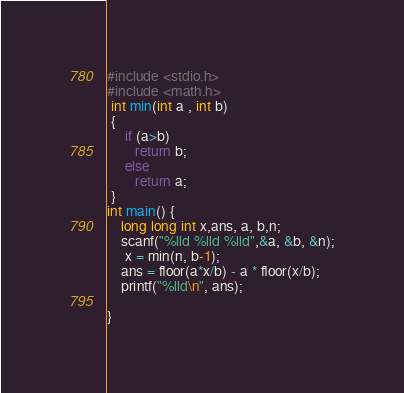Convert code to text. <code><loc_0><loc_0><loc_500><loc_500><_C++_>#include <stdio.h>
#include <math.h>
 int min(int a , int b)
 {
     if (a>b)
        return b;
     else
        return a;
 }
int main() {
    long long int x,ans, a, b,n;
    scanf("%lld %lld %lld",&a, &b, &n);
     x = min(n, b-1);
    ans = floor(a*x/b) - a * floor(x/b);
    printf("%lld\n", ans);

}
</code> 